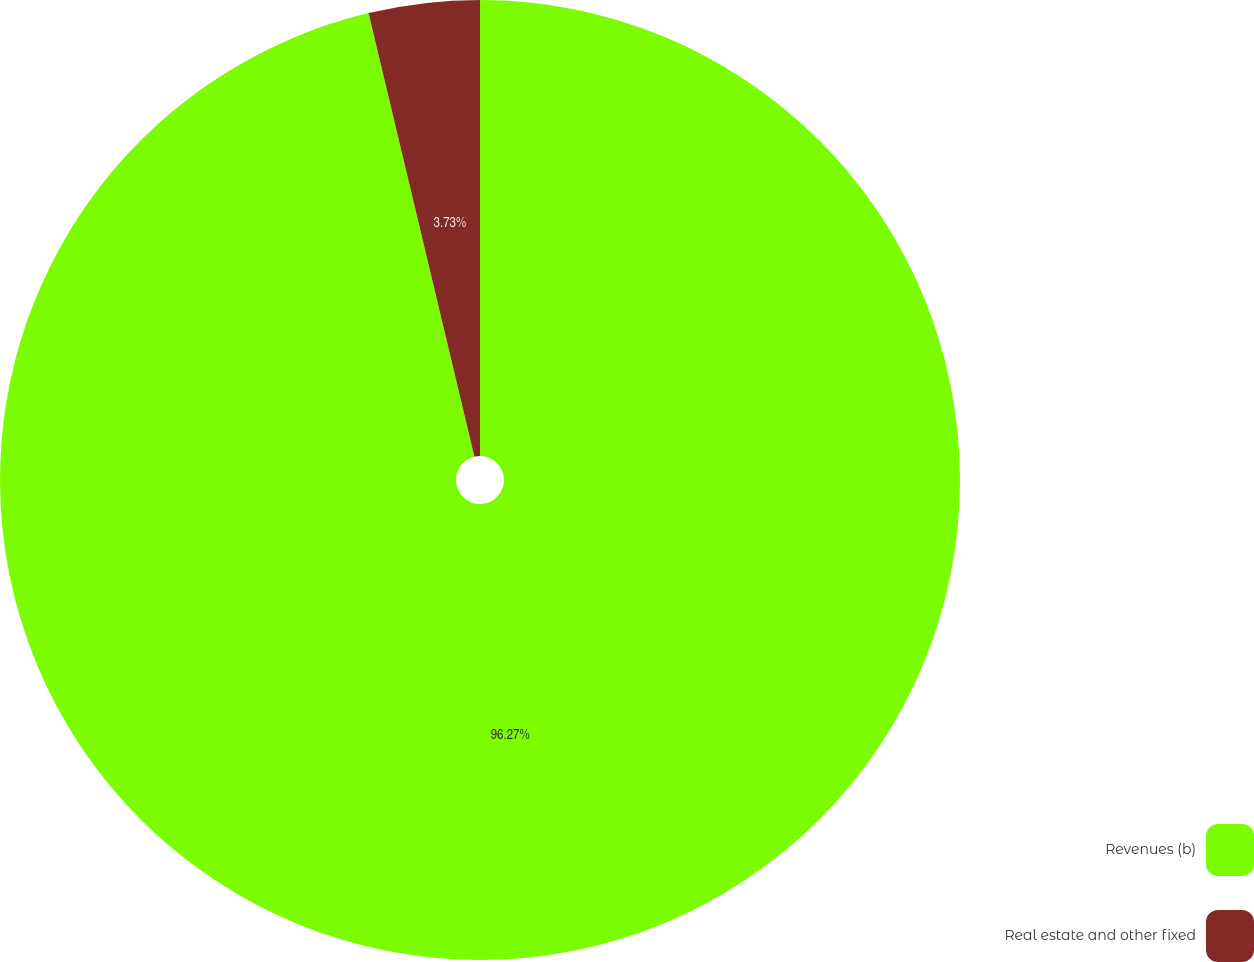Convert chart to OTSL. <chart><loc_0><loc_0><loc_500><loc_500><pie_chart><fcel>Revenues (b)<fcel>Real estate and other fixed<nl><fcel>96.27%<fcel>3.73%<nl></chart> 